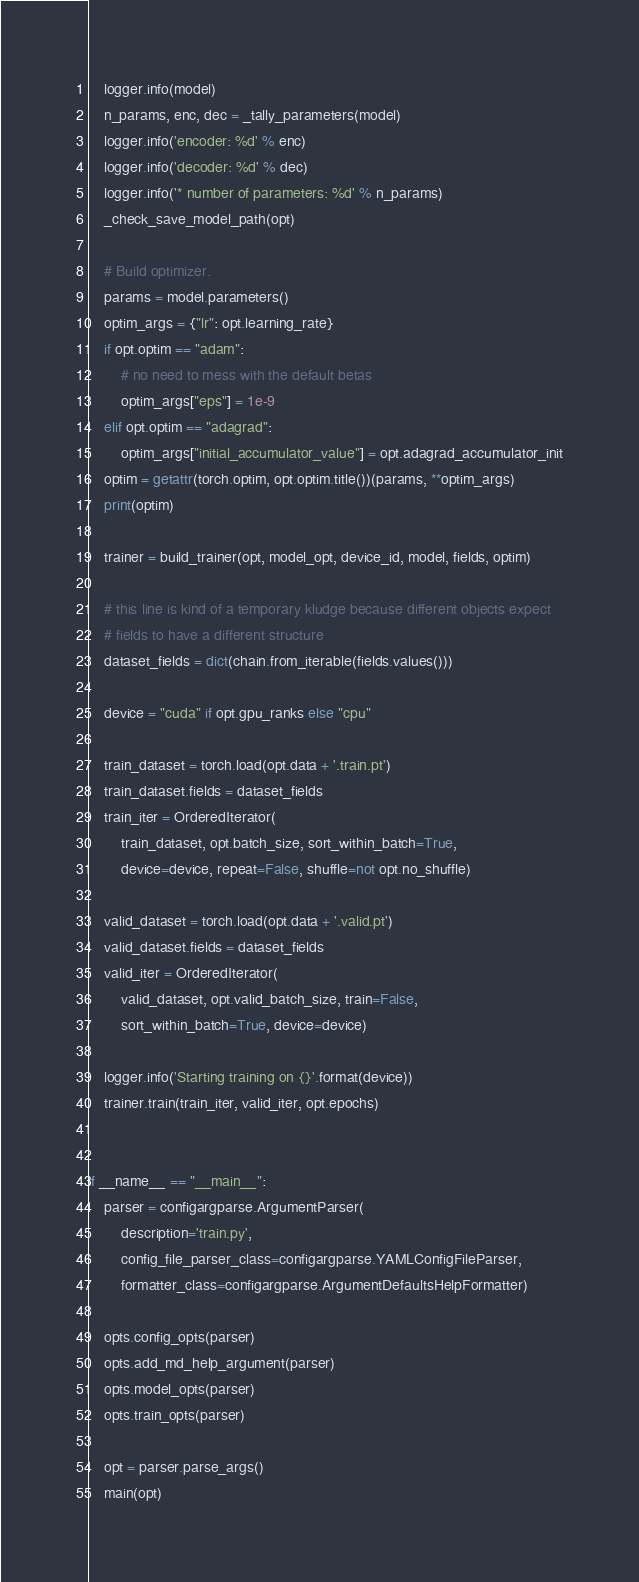<code> <loc_0><loc_0><loc_500><loc_500><_Python_>    logger.info(model)
    n_params, enc, dec = _tally_parameters(model)
    logger.info('encoder: %d' % enc)
    logger.info('decoder: %d' % dec)
    logger.info('* number of parameters: %d' % n_params)
    _check_save_model_path(opt)

    # Build optimizer.
    params = model.parameters()
    optim_args = {"lr": opt.learning_rate}
    if opt.optim == "adam":
        # no need to mess with the default betas
        optim_args["eps"] = 1e-9
    elif opt.optim == "adagrad":
        optim_args["initial_accumulator_value"] = opt.adagrad_accumulator_init
    optim = getattr(torch.optim, opt.optim.title())(params, **optim_args)
    print(optim)

    trainer = build_trainer(opt, model_opt, device_id, model, fields, optim)

    # this line is kind of a temporary kludge because different objects expect
    # fields to have a different structure
    dataset_fields = dict(chain.from_iterable(fields.values()))

    device = "cuda" if opt.gpu_ranks else "cpu"

    train_dataset = torch.load(opt.data + '.train.pt')
    train_dataset.fields = dataset_fields
    train_iter = OrderedIterator(
        train_dataset, opt.batch_size, sort_within_batch=True,
        device=device, repeat=False, shuffle=not opt.no_shuffle)

    valid_dataset = torch.load(opt.data + '.valid.pt')
    valid_dataset.fields = dataset_fields
    valid_iter = OrderedIterator(
        valid_dataset, opt.valid_batch_size, train=False,
        sort_within_batch=True, device=device)

    logger.info('Starting training on {}'.format(device))
    trainer.train(train_iter, valid_iter, opt.epochs)


if __name__ == "__main__":
    parser = configargparse.ArgumentParser(
        description='train.py',
        config_file_parser_class=configargparse.YAMLConfigFileParser,
        formatter_class=configargparse.ArgumentDefaultsHelpFormatter)

    opts.config_opts(parser)
    opts.add_md_help_argument(parser)
    opts.model_opts(parser)
    opts.train_opts(parser)

    opt = parser.parse_args()
    main(opt)
</code> 